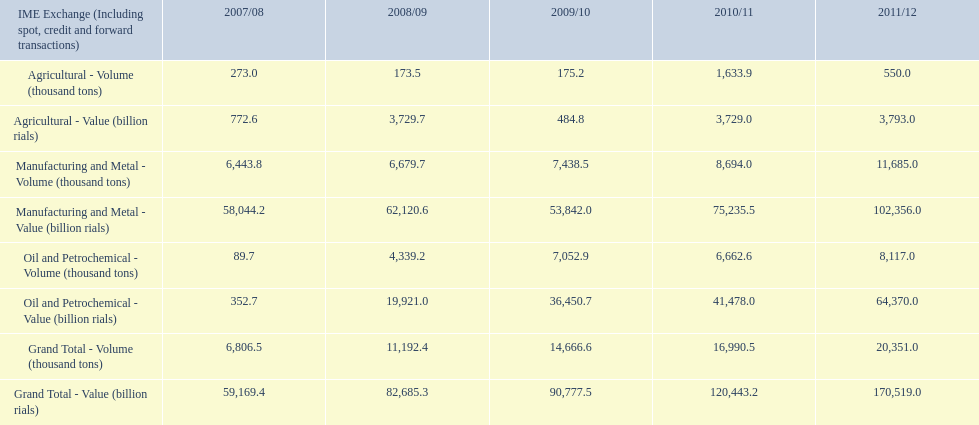Help me parse the entirety of this table. {'header': ['IME Exchange (Including spot, credit and forward transactions)', '2007/08', '2008/09', '2009/10', '2010/11', '2011/12'], 'rows': [['Agricultural - Volume (thousand tons)', '273.0', '173.5', '175.2', '1,633.9', '550.0'], ['Agricultural - Value (billion rials)', '772.6', '3,729.7', '484.8', '3,729.0', '3,793.0'], ['Manufacturing and Metal - Volume (thousand tons)', '6,443.8', '6,679.7', '7,438.5', '8,694.0', '11,685.0'], ['Manufacturing and Metal - Value (billion rials)', '58,044.2', '62,120.6', '53,842.0', '75,235.5', '102,356.0'], ['Oil and Petrochemical - Volume (thousand tons)', '89.7', '4,339.2', '7,052.9', '6,662.6', '8,117.0'], ['Oil and Petrochemical - Value (billion rials)', '352.7', '19,921.0', '36,450.7', '41,478.0', '64,370.0'], ['Grand Total - Volume (thousand tons)', '6,806.5', '11,192.4', '14,666.6', '16,990.5', '20,351.0'], ['Grand Total - Value (billion rials)', '59,169.4', '82,685.3', '90,777.5', '120,443.2', '170,519.0']]} Did 2010/11 or 2011/12 make more in grand total value? 2011/12. 